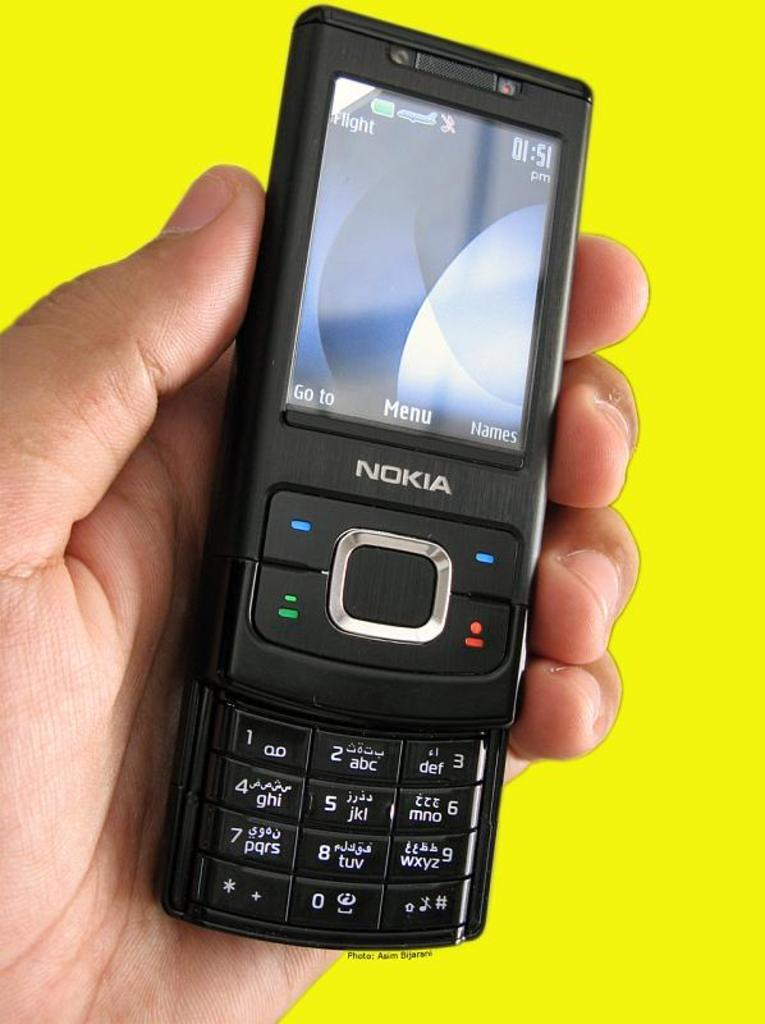<image>
Offer a succinct explanation of the picture presented. The time on the Nokia cellphone is 01:51 pm. 